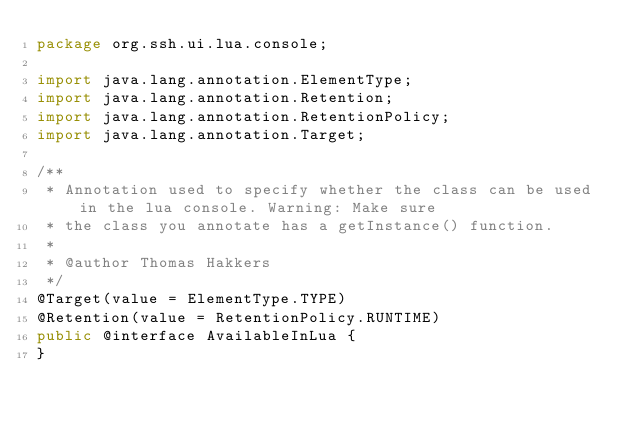Convert code to text. <code><loc_0><loc_0><loc_500><loc_500><_Java_>package org.ssh.ui.lua.console;

import java.lang.annotation.ElementType;
import java.lang.annotation.Retention;
import java.lang.annotation.RetentionPolicy;
import java.lang.annotation.Target;

/**
 * Annotation used to specify whether the class can be used in the lua console. Warning: Make sure
 * the class you annotate has a getInstance() function.
 *
 * @author Thomas Hakkers
 */
@Target(value = ElementType.TYPE)
@Retention(value = RetentionPolicy.RUNTIME)
public @interface AvailableInLua {
}
</code> 